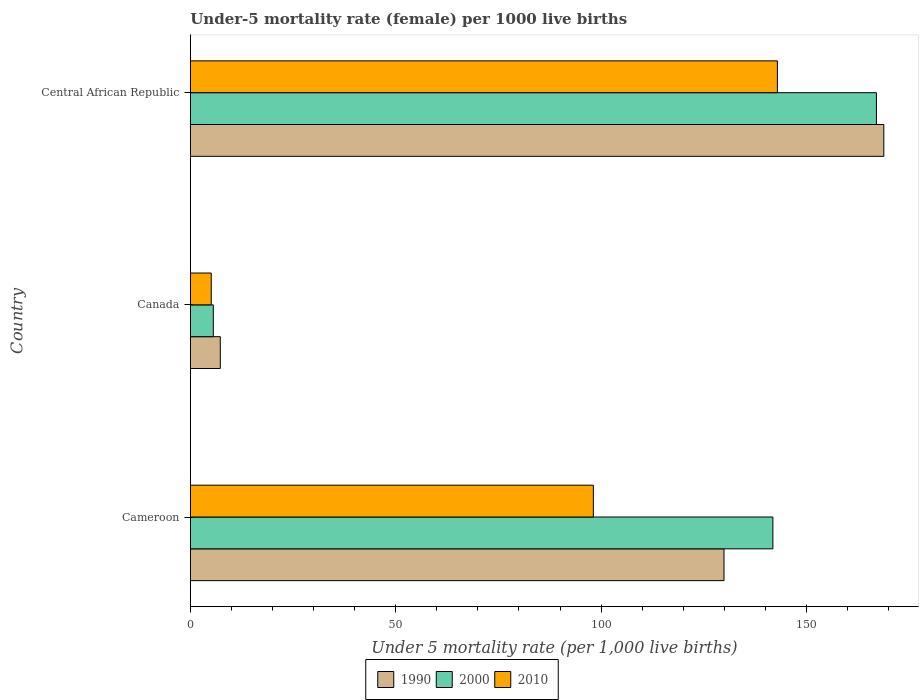How many different coloured bars are there?
Provide a short and direct response. 3. How many groups of bars are there?
Offer a terse response. 3. Are the number of bars on each tick of the Y-axis equal?
Give a very brief answer. Yes. What is the label of the 3rd group of bars from the top?
Ensure brevity in your answer.  Cameroon. In how many cases, is the number of bars for a given country not equal to the number of legend labels?
Provide a succinct answer. 0. What is the under-five mortality rate in 1990 in Cameroon?
Offer a terse response. 129.9. Across all countries, what is the maximum under-five mortality rate in 2010?
Your response must be concise. 142.9. Across all countries, what is the minimum under-five mortality rate in 2000?
Your answer should be very brief. 5.6. In which country was the under-five mortality rate in 1990 maximum?
Your answer should be very brief. Central African Republic. In which country was the under-five mortality rate in 1990 minimum?
Make the answer very short. Canada. What is the total under-five mortality rate in 2010 in the graph?
Your answer should be very brief. 246.1. What is the difference between the under-five mortality rate in 1990 in Cameroon and that in Canada?
Offer a very short reply. 122.6. What is the difference between the under-five mortality rate in 2010 in Canada and the under-five mortality rate in 2000 in Cameroon?
Give a very brief answer. -136.7. What is the average under-five mortality rate in 2000 per country?
Give a very brief answer. 104.8. What is the difference between the under-five mortality rate in 2000 and under-five mortality rate in 1990 in Cameroon?
Your answer should be compact. 11.9. In how many countries, is the under-five mortality rate in 2010 greater than 20 ?
Your answer should be very brief. 2. What is the ratio of the under-five mortality rate in 2010 in Canada to that in Central African Republic?
Your answer should be compact. 0.04. Is the under-five mortality rate in 2010 in Cameroon less than that in Central African Republic?
Ensure brevity in your answer.  Yes. What is the difference between the highest and the second highest under-five mortality rate in 1990?
Keep it short and to the point. 38.9. What is the difference between the highest and the lowest under-five mortality rate in 2010?
Offer a terse response. 137.8. In how many countries, is the under-five mortality rate in 2000 greater than the average under-five mortality rate in 2000 taken over all countries?
Give a very brief answer. 2. Is the sum of the under-five mortality rate in 1990 in Canada and Central African Republic greater than the maximum under-five mortality rate in 2000 across all countries?
Your answer should be very brief. Yes. What does the 3rd bar from the bottom in Cameroon represents?
Your response must be concise. 2010. Is it the case that in every country, the sum of the under-five mortality rate in 2000 and under-five mortality rate in 1990 is greater than the under-five mortality rate in 2010?
Ensure brevity in your answer.  Yes. How many bars are there?
Your response must be concise. 9. How many countries are there in the graph?
Ensure brevity in your answer.  3. What is the difference between two consecutive major ticks on the X-axis?
Ensure brevity in your answer.  50. Does the graph contain grids?
Provide a short and direct response. No. Where does the legend appear in the graph?
Provide a short and direct response. Bottom center. How many legend labels are there?
Your response must be concise. 3. What is the title of the graph?
Offer a terse response. Under-5 mortality rate (female) per 1000 live births. Does "1991" appear as one of the legend labels in the graph?
Your answer should be very brief. No. What is the label or title of the X-axis?
Provide a short and direct response. Under 5 mortality rate (per 1,0 live births). What is the Under 5 mortality rate (per 1,000 live births) in 1990 in Cameroon?
Offer a very short reply. 129.9. What is the Under 5 mortality rate (per 1,000 live births) of 2000 in Cameroon?
Provide a short and direct response. 141.8. What is the Under 5 mortality rate (per 1,000 live births) of 2010 in Cameroon?
Provide a succinct answer. 98.1. What is the Under 5 mortality rate (per 1,000 live births) of 1990 in Canada?
Your response must be concise. 7.3. What is the Under 5 mortality rate (per 1,000 live births) in 2010 in Canada?
Make the answer very short. 5.1. What is the Under 5 mortality rate (per 1,000 live births) of 1990 in Central African Republic?
Your answer should be very brief. 168.8. What is the Under 5 mortality rate (per 1,000 live births) of 2000 in Central African Republic?
Your response must be concise. 167. What is the Under 5 mortality rate (per 1,000 live births) in 2010 in Central African Republic?
Ensure brevity in your answer.  142.9. Across all countries, what is the maximum Under 5 mortality rate (per 1,000 live births) in 1990?
Your answer should be compact. 168.8. Across all countries, what is the maximum Under 5 mortality rate (per 1,000 live births) of 2000?
Your answer should be very brief. 167. Across all countries, what is the maximum Under 5 mortality rate (per 1,000 live births) in 2010?
Your response must be concise. 142.9. Across all countries, what is the minimum Under 5 mortality rate (per 1,000 live births) of 2010?
Your response must be concise. 5.1. What is the total Under 5 mortality rate (per 1,000 live births) in 1990 in the graph?
Your response must be concise. 306. What is the total Under 5 mortality rate (per 1,000 live births) in 2000 in the graph?
Provide a short and direct response. 314.4. What is the total Under 5 mortality rate (per 1,000 live births) of 2010 in the graph?
Provide a succinct answer. 246.1. What is the difference between the Under 5 mortality rate (per 1,000 live births) of 1990 in Cameroon and that in Canada?
Your answer should be compact. 122.6. What is the difference between the Under 5 mortality rate (per 1,000 live births) of 2000 in Cameroon and that in Canada?
Offer a terse response. 136.2. What is the difference between the Under 5 mortality rate (per 1,000 live births) of 2010 in Cameroon and that in Canada?
Make the answer very short. 93. What is the difference between the Under 5 mortality rate (per 1,000 live births) of 1990 in Cameroon and that in Central African Republic?
Your answer should be very brief. -38.9. What is the difference between the Under 5 mortality rate (per 1,000 live births) of 2000 in Cameroon and that in Central African Republic?
Offer a terse response. -25.2. What is the difference between the Under 5 mortality rate (per 1,000 live births) in 2010 in Cameroon and that in Central African Republic?
Your answer should be compact. -44.8. What is the difference between the Under 5 mortality rate (per 1,000 live births) in 1990 in Canada and that in Central African Republic?
Make the answer very short. -161.5. What is the difference between the Under 5 mortality rate (per 1,000 live births) of 2000 in Canada and that in Central African Republic?
Your answer should be compact. -161.4. What is the difference between the Under 5 mortality rate (per 1,000 live births) in 2010 in Canada and that in Central African Republic?
Make the answer very short. -137.8. What is the difference between the Under 5 mortality rate (per 1,000 live births) in 1990 in Cameroon and the Under 5 mortality rate (per 1,000 live births) in 2000 in Canada?
Provide a succinct answer. 124.3. What is the difference between the Under 5 mortality rate (per 1,000 live births) in 1990 in Cameroon and the Under 5 mortality rate (per 1,000 live births) in 2010 in Canada?
Offer a very short reply. 124.8. What is the difference between the Under 5 mortality rate (per 1,000 live births) in 2000 in Cameroon and the Under 5 mortality rate (per 1,000 live births) in 2010 in Canada?
Your answer should be very brief. 136.7. What is the difference between the Under 5 mortality rate (per 1,000 live births) of 1990 in Cameroon and the Under 5 mortality rate (per 1,000 live births) of 2000 in Central African Republic?
Make the answer very short. -37.1. What is the difference between the Under 5 mortality rate (per 1,000 live births) of 2000 in Cameroon and the Under 5 mortality rate (per 1,000 live births) of 2010 in Central African Republic?
Your response must be concise. -1.1. What is the difference between the Under 5 mortality rate (per 1,000 live births) in 1990 in Canada and the Under 5 mortality rate (per 1,000 live births) in 2000 in Central African Republic?
Provide a succinct answer. -159.7. What is the difference between the Under 5 mortality rate (per 1,000 live births) of 1990 in Canada and the Under 5 mortality rate (per 1,000 live births) of 2010 in Central African Republic?
Provide a short and direct response. -135.6. What is the difference between the Under 5 mortality rate (per 1,000 live births) in 2000 in Canada and the Under 5 mortality rate (per 1,000 live births) in 2010 in Central African Republic?
Make the answer very short. -137.3. What is the average Under 5 mortality rate (per 1,000 live births) of 1990 per country?
Your answer should be compact. 102. What is the average Under 5 mortality rate (per 1,000 live births) of 2000 per country?
Provide a short and direct response. 104.8. What is the average Under 5 mortality rate (per 1,000 live births) of 2010 per country?
Your answer should be very brief. 82.03. What is the difference between the Under 5 mortality rate (per 1,000 live births) in 1990 and Under 5 mortality rate (per 1,000 live births) in 2010 in Cameroon?
Your answer should be very brief. 31.8. What is the difference between the Under 5 mortality rate (per 1,000 live births) in 2000 and Under 5 mortality rate (per 1,000 live births) in 2010 in Cameroon?
Provide a succinct answer. 43.7. What is the difference between the Under 5 mortality rate (per 1,000 live births) in 1990 and Under 5 mortality rate (per 1,000 live births) in 2000 in Canada?
Ensure brevity in your answer.  1.7. What is the difference between the Under 5 mortality rate (per 1,000 live births) of 1990 and Under 5 mortality rate (per 1,000 live births) of 2010 in Canada?
Provide a succinct answer. 2.2. What is the difference between the Under 5 mortality rate (per 1,000 live births) in 1990 and Under 5 mortality rate (per 1,000 live births) in 2000 in Central African Republic?
Your answer should be compact. 1.8. What is the difference between the Under 5 mortality rate (per 1,000 live births) of 1990 and Under 5 mortality rate (per 1,000 live births) of 2010 in Central African Republic?
Keep it short and to the point. 25.9. What is the difference between the Under 5 mortality rate (per 1,000 live births) of 2000 and Under 5 mortality rate (per 1,000 live births) of 2010 in Central African Republic?
Provide a short and direct response. 24.1. What is the ratio of the Under 5 mortality rate (per 1,000 live births) in 1990 in Cameroon to that in Canada?
Your answer should be very brief. 17.79. What is the ratio of the Under 5 mortality rate (per 1,000 live births) of 2000 in Cameroon to that in Canada?
Provide a short and direct response. 25.32. What is the ratio of the Under 5 mortality rate (per 1,000 live births) in 2010 in Cameroon to that in Canada?
Give a very brief answer. 19.24. What is the ratio of the Under 5 mortality rate (per 1,000 live births) of 1990 in Cameroon to that in Central African Republic?
Offer a terse response. 0.77. What is the ratio of the Under 5 mortality rate (per 1,000 live births) of 2000 in Cameroon to that in Central African Republic?
Make the answer very short. 0.85. What is the ratio of the Under 5 mortality rate (per 1,000 live births) in 2010 in Cameroon to that in Central African Republic?
Your answer should be compact. 0.69. What is the ratio of the Under 5 mortality rate (per 1,000 live births) in 1990 in Canada to that in Central African Republic?
Provide a short and direct response. 0.04. What is the ratio of the Under 5 mortality rate (per 1,000 live births) in 2000 in Canada to that in Central African Republic?
Give a very brief answer. 0.03. What is the ratio of the Under 5 mortality rate (per 1,000 live births) of 2010 in Canada to that in Central African Republic?
Keep it short and to the point. 0.04. What is the difference between the highest and the second highest Under 5 mortality rate (per 1,000 live births) of 1990?
Give a very brief answer. 38.9. What is the difference between the highest and the second highest Under 5 mortality rate (per 1,000 live births) in 2000?
Offer a very short reply. 25.2. What is the difference between the highest and the second highest Under 5 mortality rate (per 1,000 live births) in 2010?
Give a very brief answer. 44.8. What is the difference between the highest and the lowest Under 5 mortality rate (per 1,000 live births) in 1990?
Provide a succinct answer. 161.5. What is the difference between the highest and the lowest Under 5 mortality rate (per 1,000 live births) of 2000?
Your answer should be very brief. 161.4. What is the difference between the highest and the lowest Under 5 mortality rate (per 1,000 live births) of 2010?
Your response must be concise. 137.8. 